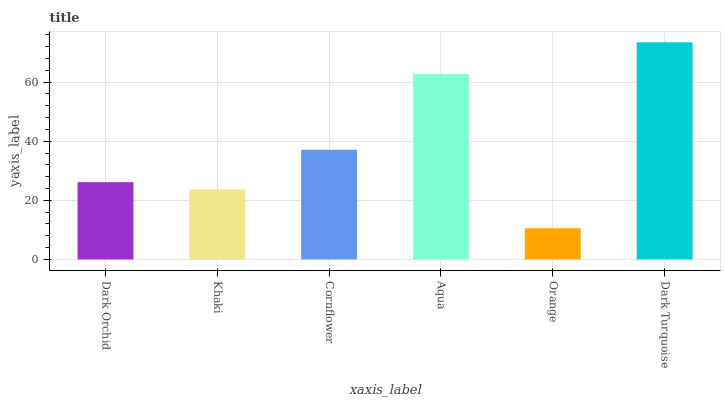Is Orange the minimum?
Answer yes or no. Yes. Is Dark Turquoise the maximum?
Answer yes or no. Yes. Is Khaki the minimum?
Answer yes or no. No. Is Khaki the maximum?
Answer yes or no. No. Is Dark Orchid greater than Khaki?
Answer yes or no. Yes. Is Khaki less than Dark Orchid?
Answer yes or no. Yes. Is Khaki greater than Dark Orchid?
Answer yes or no. No. Is Dark Orchid less than Khaki?
Answer yes or no. No. Is Cornflower the high median?
Answer yes or no. Yes. Is Dark Orchid the low median?
Answer yes or no. Yes. Is Dark Turquoise the high median?
Answer yes or no. No. Is Cornflower the low median?
Answer yes or no. No. 